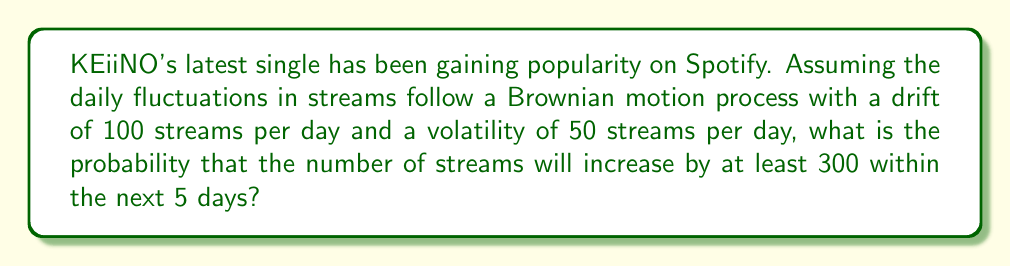Teach me how to tackle this problem. Let's approach this step-by-step:

1) In a Brownian motion process, the change in the number of streams over a time period $t$ follows a normal distribution with:
   Mean = $\mu t$
   Variance = $\sigma^2 t$

   Where $\mu$ is the drift and $\sigma$ is the volatility.

2) Given:
   $\mu = 100$ streams/day
   $\sigma = 50$ streams/day
   $t = 5$ days

3) Calculate the mean and standard deviation for the 5-day period:
   Mean = $\mu t = 100 \cdot 5 = 500$ streams
   Standard deviation = $\sigma \sqrt{t} = 50 \sqrt{5} \approx 111.8$ streams

4) We want to find $P(X \geq 300)$, where $X$ is the increase in streams.

5) Standardize the random variable:
   $Z = \frac{X - \mu t}{\sigma \sqrt{t}} = \frac{300 - 500}{111.8} \approx -1.79$

6) We need to find $P(Z \geq -1.79)$

7) Using the standard normal distribution table or calculator:
   $P(Z \geq -1.79) = 1 - P(Z < -1.79) = 1 - 0.0367 = 0.9633$

Therefore, the probability that the number of streams will increase by at least 300 within the next 5 days is approximately 0.9633 or 96.33%.
Answer: 0.9633 